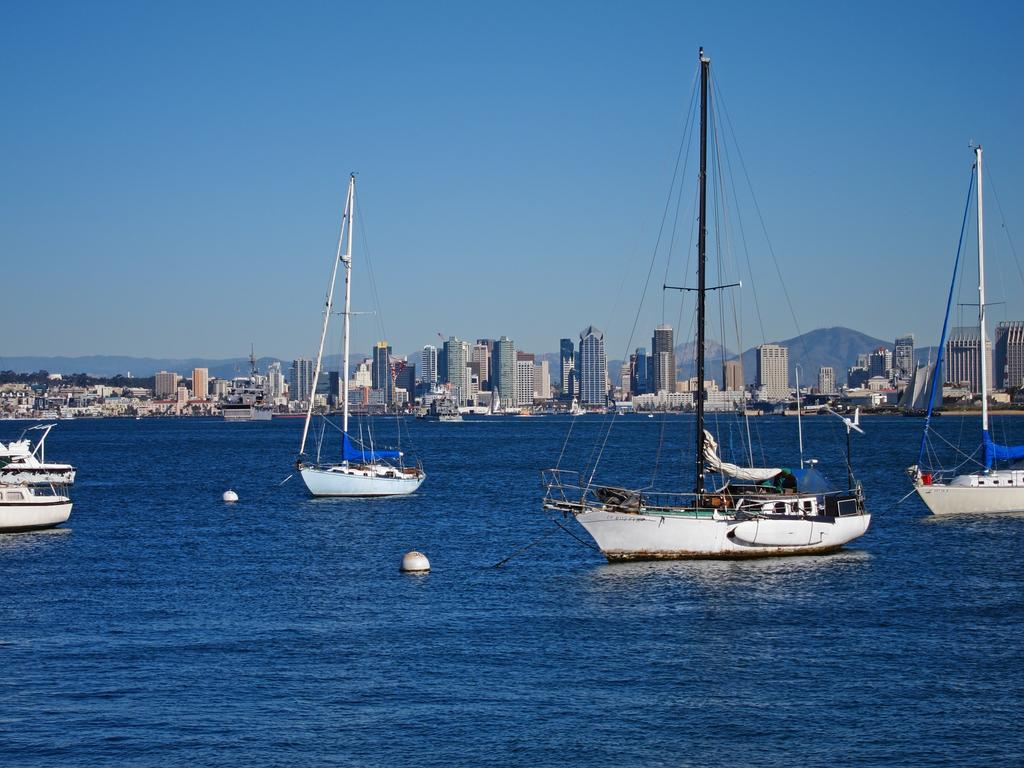What is the main subject of the image? The main subject of the image is many boats. Where are the boats located? The boats are on the water. What can be seen in the background of the image? There are buildings and the sky visible in the background of the image. How many beds can be seen in the image? There are no beds present in the image; it features boats on the water. What shape is the detail on the boats in the image? There is no specific detail mentioned in the facts, and the image does not show any shapes on the boats. 